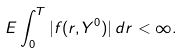<formula> <loc_0><loc_0><loc_500><loc_500>E \int ^ { T } _ { 0 } | f ( r , Y ^ { 0 } ) | \, d r < \infty .</formula> 